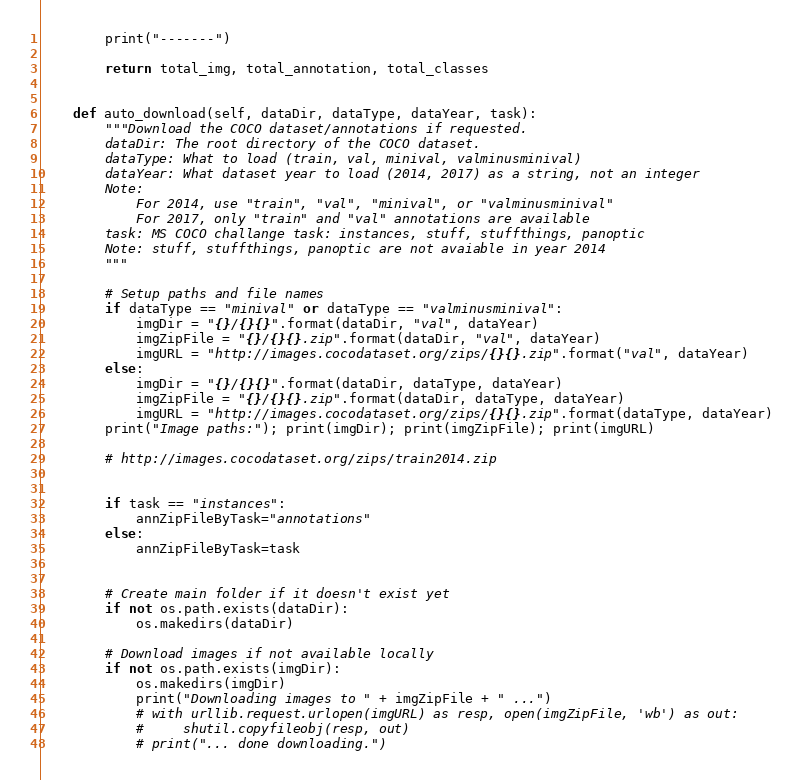Convert code to text. <code><loc_0><loc_0><loc_500><loc_500><_Python_>        print("-------")

        return total_img, total_annotation, total_classes


    def auto_download(self, dataDir, dataType, dataYear, task):
        """Download the COCO dataset/annotations if requested.
        dataDir: The root directory of the COCO dataset.
        dataType: What to load (train, val, minival, valminusminival)
        dataYear: What dataset year to load (2014, 2017) as a string, not an integer
        Note:
            For 2014, use "train", "val", "minival", or "valminusminival"
            For 2017, only "train" and "val" annotations are available
        task: MS COCO challange task: instances, stuff, stuffthings, panoptic
        Note: stuff, stuffthings, panoptic are not avaiable in year 2014
        """

        # Setup paths and file names
        if dataType == "minival" or dataType == "valminusminival":
            imgDir = "{}/{}{}".format(dataDir, "val", dataYear)
            imgZipFile = "{}/{}{}.zip".format(dataDir, "val", dataYear)
            imgURL = "http://images.cocodataset.org/zips/{}{}.zip".format("val", dataYear)
        else:
            imgDir = "{}/{}{}".format(dataDir, dataType, dataYear)
            imgZipFile = "{}/{}{}.zip".format(dataDir, dataType, dataYear)
            imgURL = "http://images.cocodataset.org/zips/{}{}.zip".format(dataType, dataYear)
        print("Image paths:"); print(imgDir); print(imgZipFile); print(imgURL)

        # http://images.cocodataset.org/zips/train2014.zip


        if task == "instances":
            annZipFileByTask="annotations"
        else:
            annZipFileByTask=task
        

        # Create main folder if it doesn't exist yet
        if not os.path.exists(dataDir):
            os.makedirs(dataDir)

        # Download images if not available locally
        if not os.path.exists(imgDir):
            os.makedirs(imgDir)
            print("Downloading images to " + imgZipFile + " ...")
            # with urllib.request.urlopen(imgURL) as resp, open(imgZipFile, 'wb') as out:
            #     shutil.copyfileobj(resp, out)
            # print("... done downloading.")</code> 